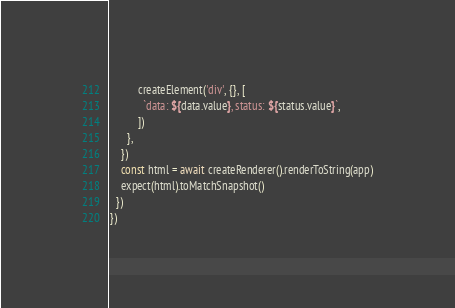Convert code to text. <code><loc_0><loc_0><loc_500><loc_500><_TypeScript_>          createElement('div', {}, [
            `data: ${data.value}, status: ${status.value}`,
          ])
      },
    })
    const html = await createRenderer().renderToString(app)
    expect(html).toMatchSnapshot()
  })
})
</code> 